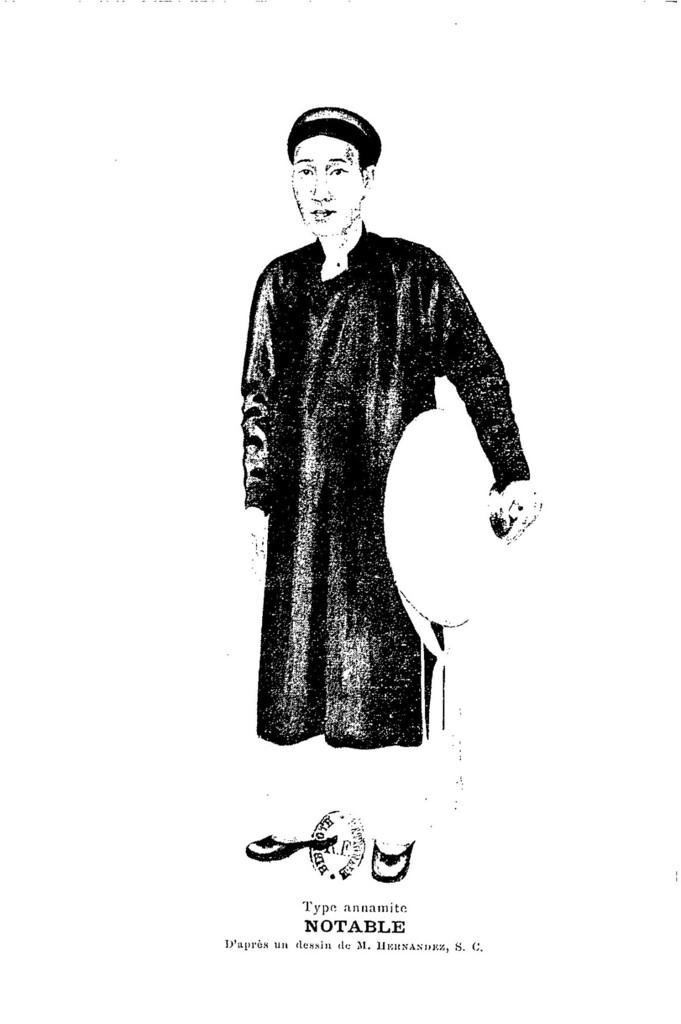What is the main subject of the image? The main subject of the image is a sketch of a person. What else can be seen in the image besides the sketch? There is text in the image. How many brothers does the person in the sketch have, according to the image? There is no information about the person's brothers in the image, as it only contains a sketch of a person and text. 